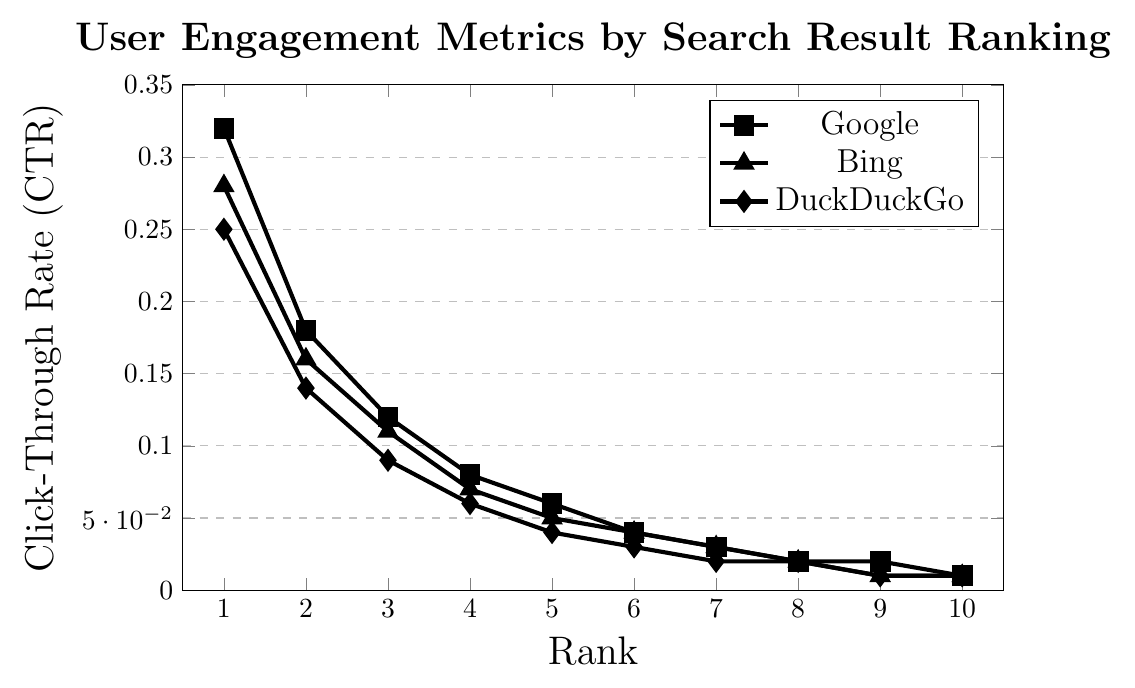what's the click-through rate (CTR) for the top-ranked result on DuckDuckGo? The plot indicates that the click-through rate (CTR) for DuckDuckGo for the first-ranked search result is shown by a diamond marker corresponding to the value on the vertical axis. The CTR for the first rank is 0.25.
Answer: 0.25 how does the CTR for the second-ranked result on Google compare to that of Bing? The second-ranked result's CTR on Google is 0.18 and on Bing it's 0.16. Comparing these values, Google's CTR (0.18) is slightly higher than Bing's CTR (0.16).
Answer: Google's CTR is higher which search engine has the lowest CTR for the fifth-ranked result? According to the plot, the fifth-ranked result's CTR is 0.06 for Google, 0.05 for Bing, and 0.04 for DuckDuckGo. Comparing these values, DuckDuckGo has the lowest CTR.
Answer: DuckDuckGo what is the sum of the click-through rates (CTR) for the top three ranked results on Google? The CTR for the top three results on Google are 0.32, 0.18, and 0.12. Summing these values, 0.32 + 0.18 + 0.12 = 0.62.
Answer: 0.62 how much time on average do users spend on the top-ranked page across all three search engines? The time spent on the top-ranked page is 45 seconds for Google, 42 seconds for Bing, and 38 seconds for DuckDuckGo. The average is calculated as (45 + 42 + 38)/3 = 125/3 ≈ 41.67 seconds.
Answer: 41.67 seconds which search engine shows the steepest decline in CTR from the first to the second rank? Google’s CTR drops from 0.32 to 0.18 (a difference of 0.14), Bing's CTR drops from 0.28 to 0.16 (a difference of 0.12), and DuckDuckGo's CTR drops from 0.25 to 0.14 (a difference of 0.11). Google shows the steepest decline with a difference of 0.14.
Answer: Google what is the average click-through rate (CTR) for ranks 7, 8, and 9 on Bing? The CTR for Bing are 0.03 for rank 7, 0.02 for rank 8, and 0.01 for rank 9. The average CTR is calculated as (0.03 + 0.02 + 0.01)/3 = 0.06/3 = 0.02.
Answer: 0.02 which ranks have the same CTR across all search engines? Reviewing the values for each rank on the plot, the ranks where the CTR values are the same across all search engines are for rank 9 and rank 10.
Answer: Ranks 9 and 10 